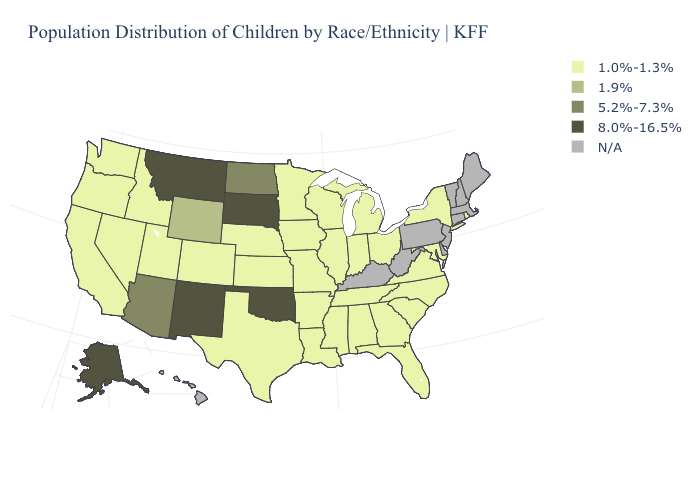Which states hav the highest value in the MidWest?
Short answer required. South Dakota. Name the states that have a value in the range 1.0%-1.3%?
Give a very brief answer. Alabama, Arkansas, California, Colorado, Florida, Georgia, Idaho, Illinois, Indiana, Iowa, Kansas, Louisiana, Maryland, Michigan, Minnesota, Mississippi, Missouri, Nebraska, Nevada, New York, North Carolina, Ohio, Oregon, Rhode Island, South Carolina, Tennessee, Texas, Utah, Virginia, Washington, Wisconsin. What is the highest value in states that border Delaware?
Be succinct. 1.0%-1.3%. What is the value of Hawaii?
Short answer required. N/A. What is the value of Nevada?
Concise answer only. 1.0%-1.3%. Name the states that have a value in the range 1.9%?
Keep it brief. Wyoming. Does Oklahoma have the lowest value in the USA?
Write a very short answer. No. What is the value of Utah?
Keep it brief. 1.0%-1.3%. Does Colorado have the lowest value in the West?
Write a very short answer. Yes. What is the value of Washington?
Quick response, please. 1.0%-1.3%. Name the states that have a value in the range 1.9%?
Give a very brief answer. Wyoming. Among the states that border Idaho , does Montana have the lowest value?
Answer briefly. No. Name the states that have a value in the range 1.0%-1.3%?
Be succinct. Alabama, Arkansas, California, Colorado, Florida, Georgia, Idaho, Illinois, Indiana, Iowa, Kansas, Louisiana, Maryland, Michigan, Minnesota, Mississippi, Missouri, Nebraska, Nevada, New York, North Carolina, Ohio, Oregon, Rhode Island, South Carolina, Tennessee, Texas, Utah, Virginia, Washington, Wisconsin. Which states have the highest value in the USA?
Quick response, please. Alaska, Montana, New Mexico, Oklahoma, South Dakota. 